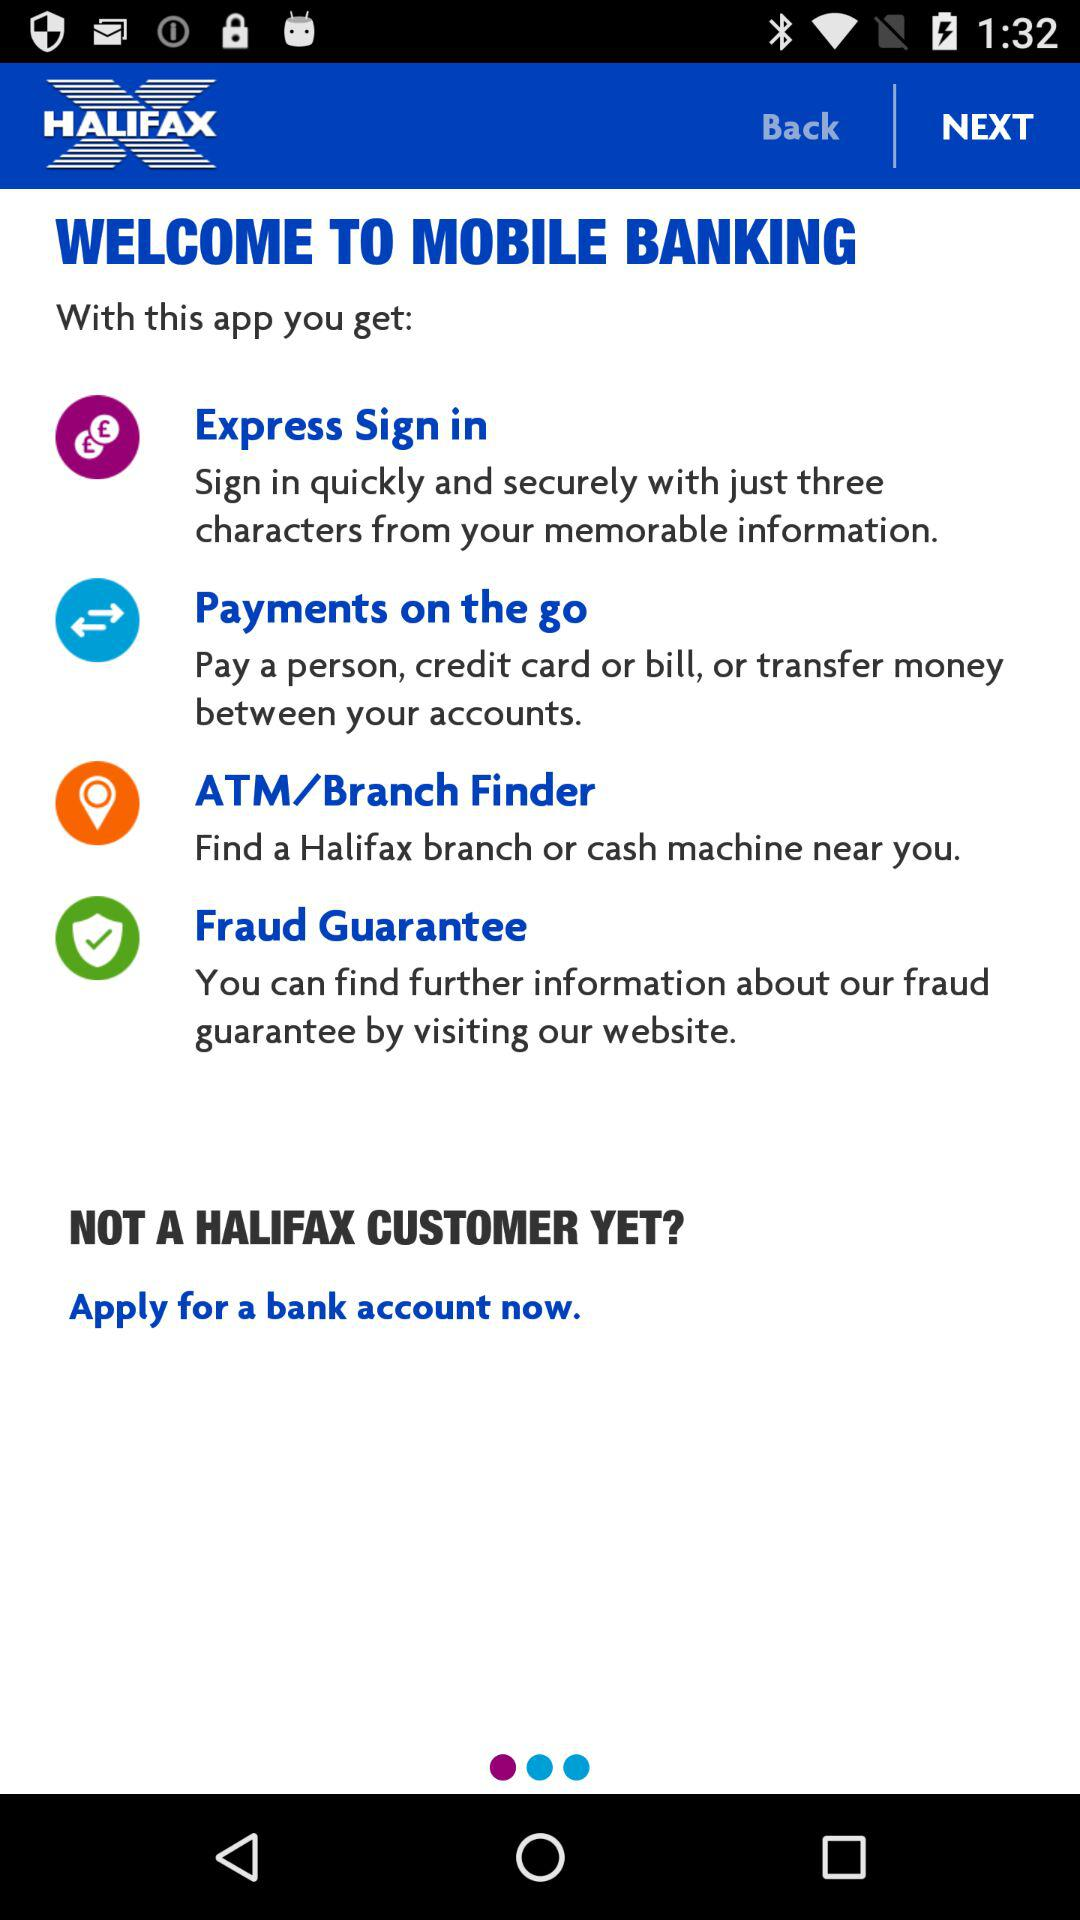What is the name of application? The name of the application is "Halifax Mobile Banking". 